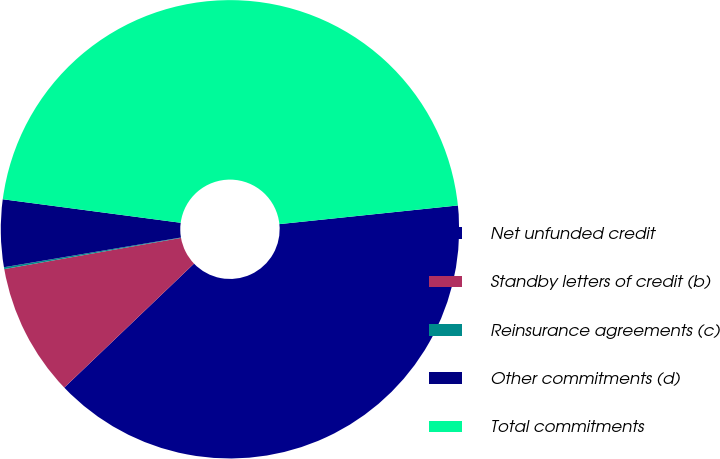<chart> <loc_0><loc_0><loc_500><loc_500><pie_chart><fcel>Net unfunded credit<fcel>Standby letters of credit (b)<fcel>Reinsurance agreements (c)<fcel>Other commitments (d)<fcel>Total commitments<nl><fcel>39.52%<fcel>9.36%<fcel>0.13%<fcel>4.74%<fcel>46.25%<nl></chart> 